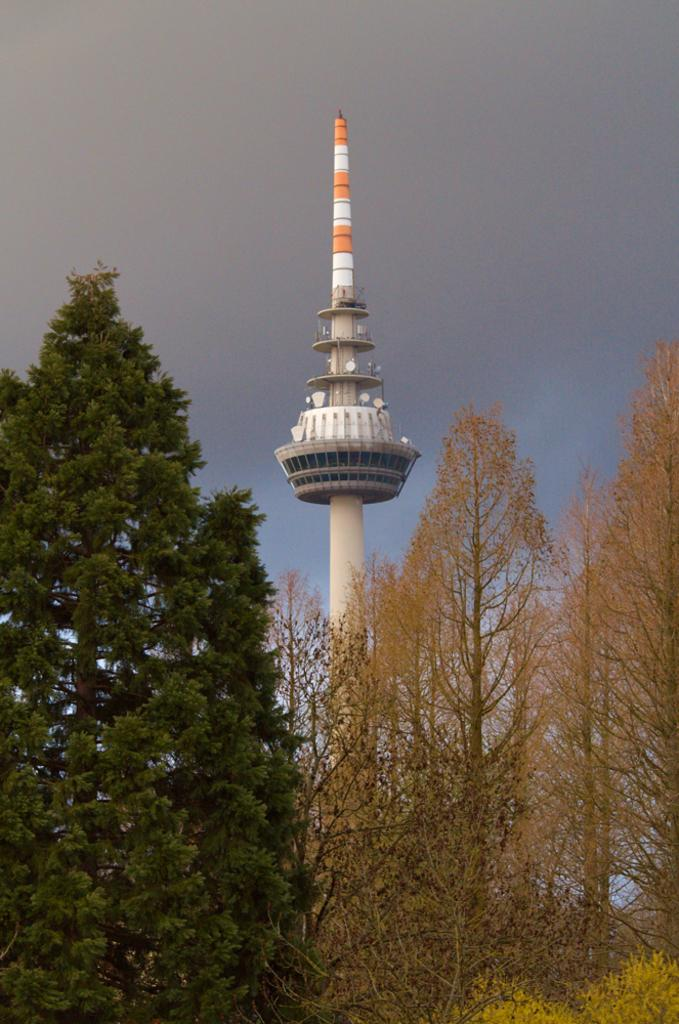What type of natural environment is depicted in the image? There are many trees in the image, indicating a natural environment. What structure can be seen in the background of the image? There is a tower visible in the background of the image. What is visible at the top of the image? The sky is visible at the top of the image. Where was the image taken? The image was taken outside the city. How many people are visible in the crowd in the image? There is no crowd present in the image; it features a natural environment with trees and a tower in the background. 